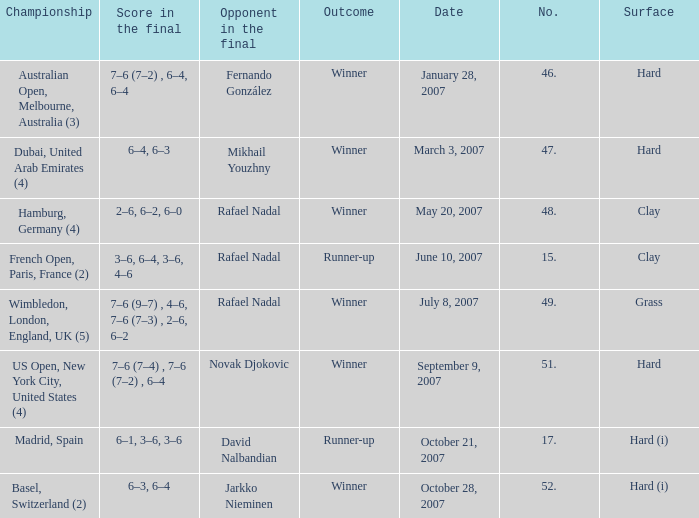On the date October 21, 2007, what is the No.? 17.0. 